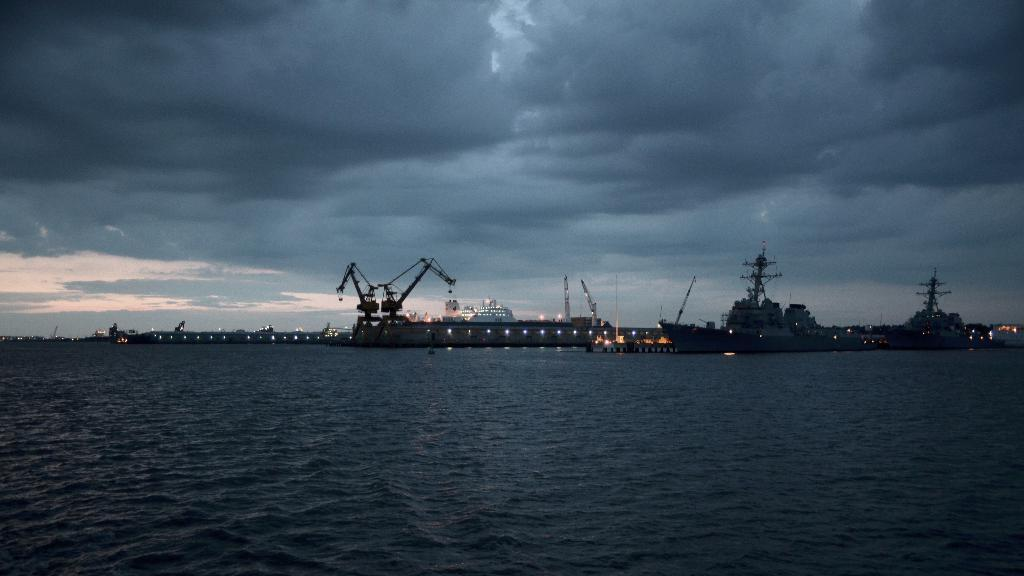What type of body of water is present in the image? There is an ocean in the image. What is floating on the water in the image? There are ships floating on the water in the image. What can be seen in the background of the image? The sky is visible in the background of the image. What is the condition of the sky in the image? There are clouds in the sky in the image. What type of bean is being roasted on the deck of one of the ships in the image? There is no bean present in the image, nor is there any indication of a bean being roasted on a ship. 